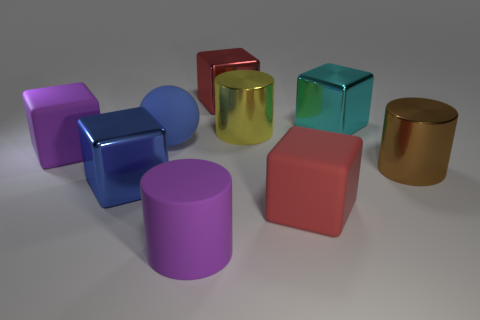Subtract all purple blocks. How many blocks are left? 4 Subtract all cyan metal blocks. How many blocks are left? 4 Subtract all brown cubes. Subtract all cyan cylinders. How many cubes are left? 5 Subtract all cylinders. How many objects are left? 6 Subtract 0 purple balls. How many objects are left? 9 Subtract all red matte cylinders. Subtract all shiny blocks. How many objects are left? 6 Add 7 yellow metallic cylinders. How many yellow metallic cylinders are left? 8 Add 8 blue matte things. How many blue matte things exist? 9 